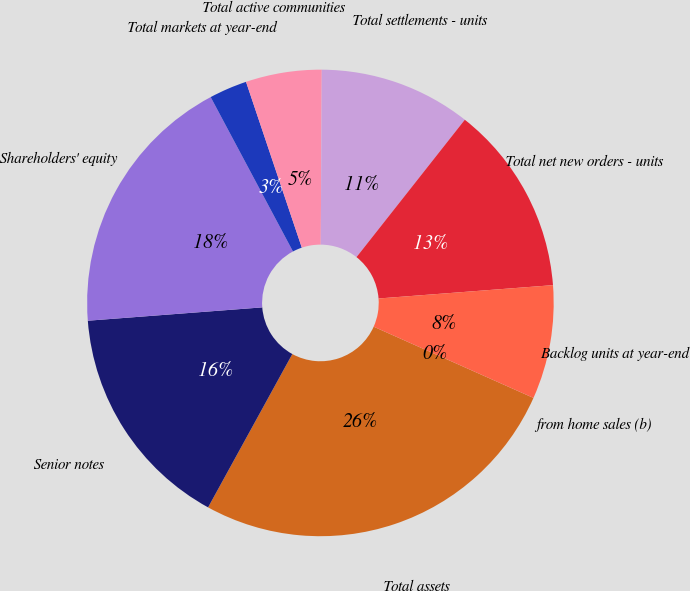<chart> <loc_0><loc_0><loc_500><loc_500><pie_chart><fcel>Total assets<fcel>Senior notes<fcel>Shareholders' equity<fcel>Total markets at year-end<fcel>Total active communities<fcel>Total settlements - units<fcel>Total net new orders - units<fcel>Backlog units at year-end<fcel>from home sales (b)<nl><fcel>26.32%<fcel>15.79%<fcel>18.42%<fcel>2.63%<fcel>5.26%<fcel>10.53%<fcel>13.16%<fcel>7.89%<fcel>0.0%<nl></chart> 